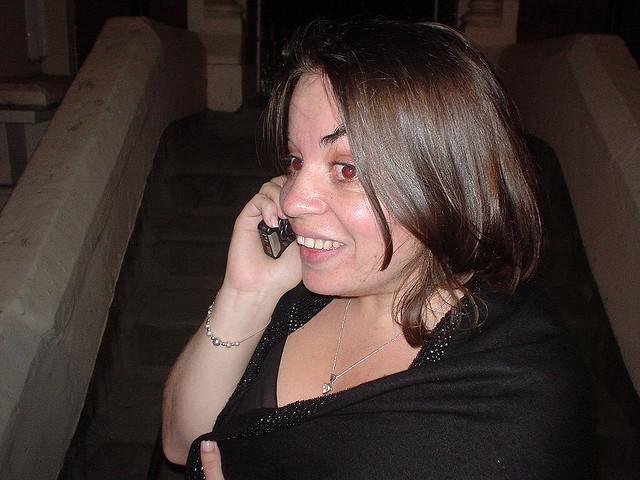How many people are in the photo?
Be succinct. 1. What is the woman holding?
Answer briefly. Phone. What shape in the pendant of the necklace?
Be succinct. Heart. What is this woman doing?
Concise answer only. Talking on phone. Is the woman's hair wet?
Quick response, please. No. Where is the woman staring?
Concise answer only. Left. What item is the person holding?
Keep it brief. Phone. What colors do you see on her nails?
Keep it brief. Clear. Is this a male or female?
Quick response, please. Female. What color is the woman's hair?
Keep it brief. Brown. What is the woman's hairstyle?
Concise answer only. Bob. What color is this woman's hair?
Concise answer only. Brown. What is she doing?
Keep it brief. Talking on phone. What color is her hair?
Answer briefly. Brown. Which hand is holding the phone?
Concise answer only. Right. Is her face painted?
Answer briefly. No. Are the stones in the woman's necklace more likely to be rubies, or topaz?
Write a very short answer. Topaz. What is around the woman's neck?
Write a very short answer. Necklace. Does she look sexy?
Concise answer only. No. What color is the woman's necklace?
Short answer required. Silver. Does she have glasses on her head?
Concise answer only. No. What is the woman wearing on her wrist?
Give a very brief answer. Bracelet. Is her  hair long?
Concise answer only. Yes. 